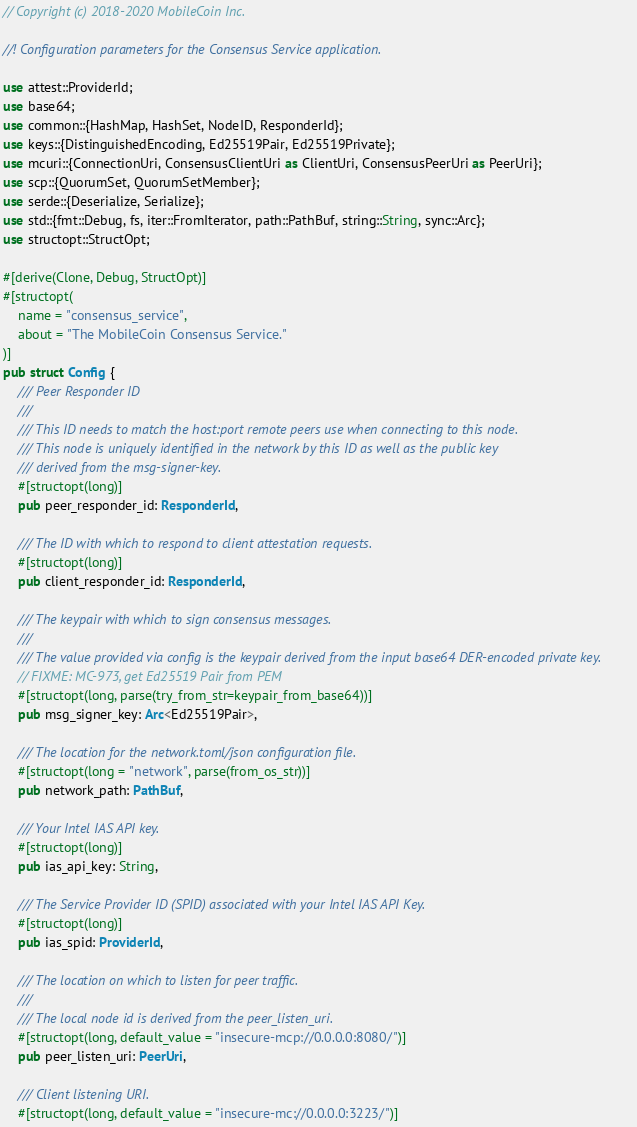<code> <loc_0><loc_0><loc_500><loc_500><_Rust_>// Copyright (c) 2018-2020 MobileCoin Inc.

//! Configuration parameters for the Consensus Service application.

use attest::ProviderId;
use base64;
use common::{HashMap, HashSet, NodeID, ResponderId};
use keys::{DistinguishedEncoding, Ed25519Pair, Ed25519Private};
use mcuri::{ConnectionUri, ConsensusClientUri as ClientUri, ConsensusPeerUri as PeerUri};
use scp::{QuorumSet, QuorumSetMember};
use serde::{Deserialize, Serialize};
use std::{fmt::Debug, fs, iter::FromIterator, path::PathBuf, string::String, sync::Arc};
use structopt::StructOpt;

#[derive(Clone, Debug, StructOpt)]
#[structopt(
    name = "consensus_service",
    about = "The MobileCoin Consensus Service."
)]
pub struct Config {
    /// Peer Responder ID
    ///
    /// This ID needs to match the host:port remote peers use when connecting to this node.
    /// This node is uniquely identified in the network by this ID as well as the public key
    /// derived from the msg-signer-key.
    #[structopt(long)]
    pub peer_responder_id: ResponderId,

    /// The ID with which to respond to client attestation requests.
    #[structopt(long)]
    pub client_responder_id: ResponderId,

    /// The keypair with which to sign consensus messages.
    ///
    /// The value provided via config is the keypair derived from the input base64 DER-encoded private key.
    // FIXME: MC-973, get Ed25519 Pair from PEM
    #[structopt(long, parse(try_from_str=keypair_from_base64))]
    pub msg_signer_key: Arc<Ed25519Pair>,

    /// The location for the network.toml/json configuration file.
    #[structopt(long = "network", parse(from_os_str))]
    pub network_path: PathBuf,

    /// Your Intel IAS API key.
    #[structopt(long)]
    pub ias_api_key: String,

    /// The Service Provider ID (SPID) associated with your Intel IAS API Key.
    #[structopt(long)]
    pub ias_spid: ProviderId,

    /// The location on which to listen for peer traffic.
    ///
    /// The local node id is derived from the peer_listen_uri.
    #[structopt(long, default_value = "insecure-mcp://0.0.0.0:8080/")]
    pub peer_listen_uri: PeerUri,

    /// Client listening URI.
    #[structopt(long, default_value = "insecure-mc://0.0.0.0:3223/")]</code> 